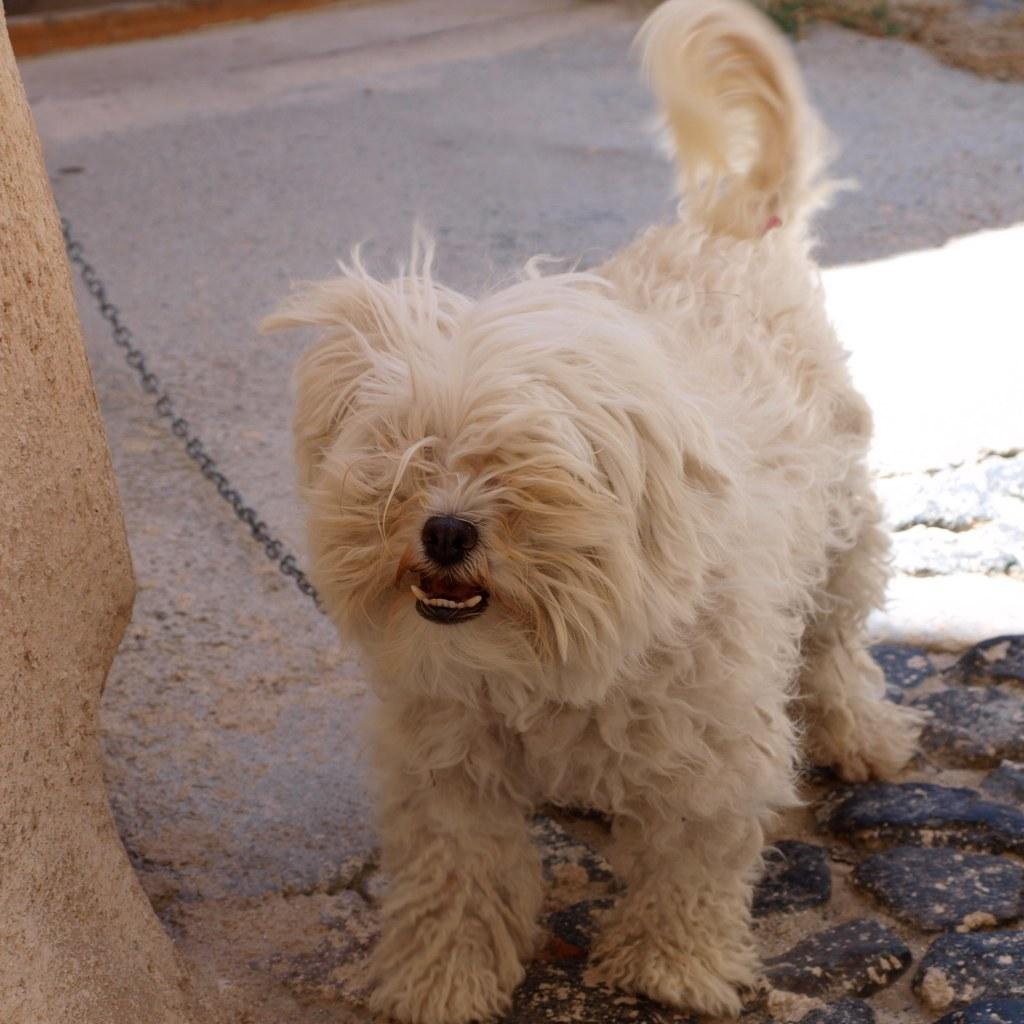What type of animal is in the image? There is a dog in the image. What color is the dog? The dog is cream in color. What is attached to the dog in the image? There is a chain visible in the image. What can be seen in the background of the image? There is a path in the image. What type of line can be seen leading to the sea in the image? There is no line or sea present in the image; it features a dog with a chain and a path in the background. 